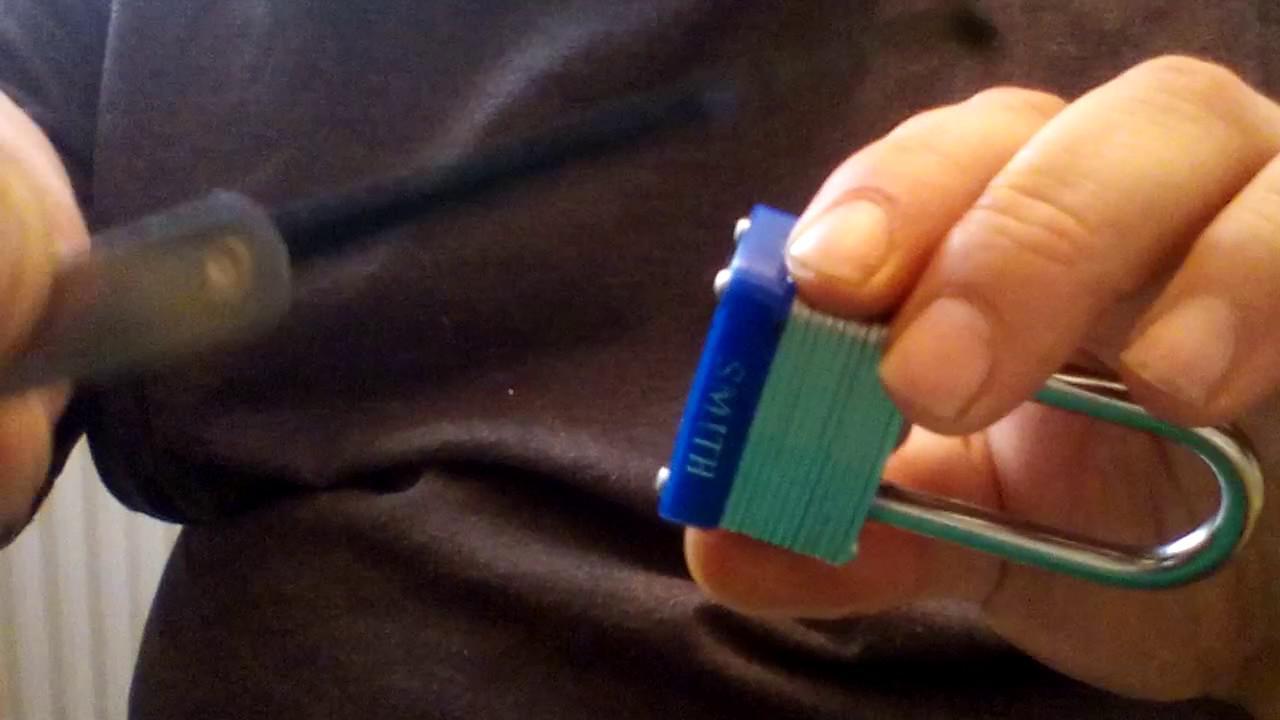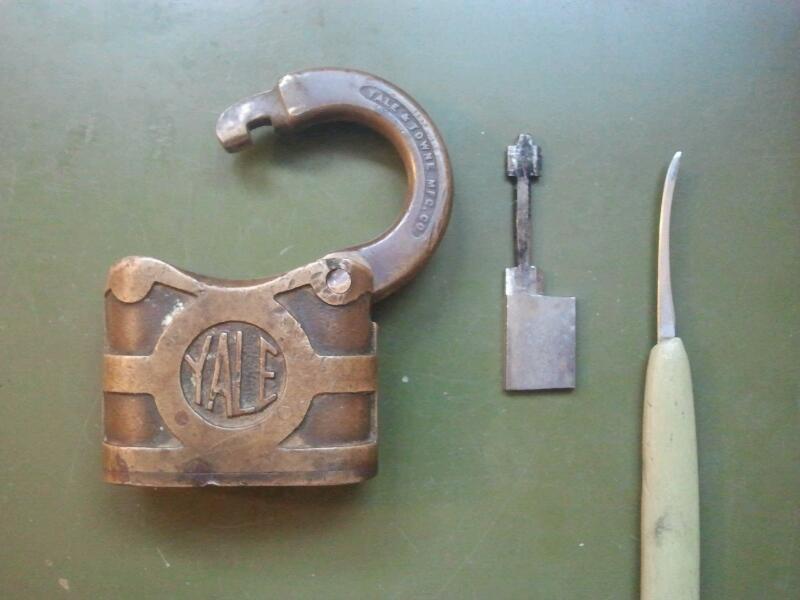The first image is the image on the left, the second image is the image on the right. Considering the images on both sides, is "The left image shows a hand holding a pointed object that is not inserted in the lock's keyhole." valid? Answer yes or no. Yes. 